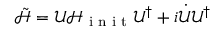<formula> <loc_0><loc_0><loc_500><loc_500>\tilde { \mathcal { H } } = { \mathcal { U } } { \mathcal { H } } _ { i n i t } { \mathcal { U } } ^ { \dagger } + i \dot { { \mathcal { U } } } { \mathcal { U } } ^ { \dagger }</formula> 